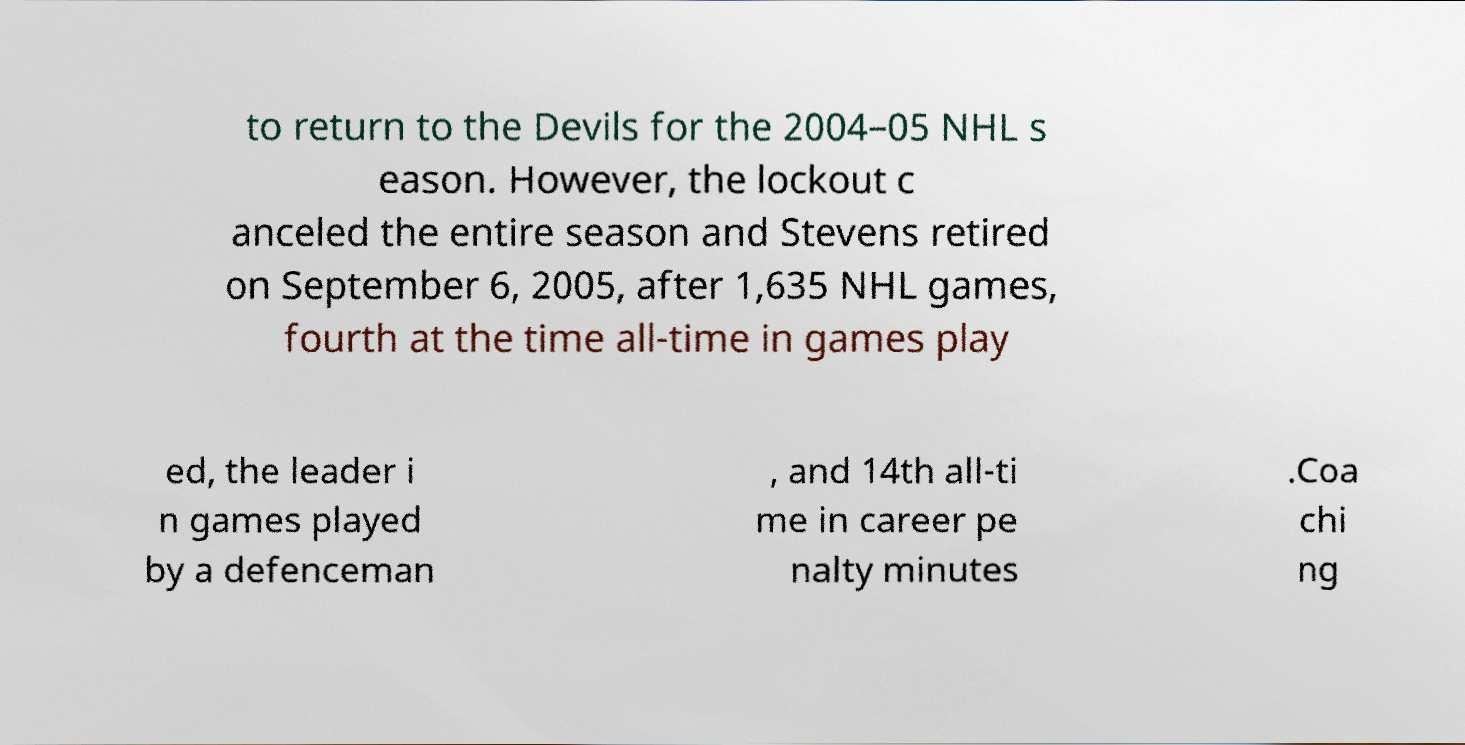Please identify and transcribe the text found in this image. to return to the Devils for the 2004–05 NHL s eason. However, the lockout c anceled the entire season and Stevens retired on September 6, 2005, after 1,635 NHL games, fourth at the time all-time in games play ed, the leader i n games played by a defenceman , and 14th all-ti me in career pe nalty minutes .Coa chi ng 